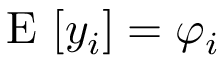Convert formula to latex. <formula><loc_0><loc_0><loc_500><loc_500>E [ y _ { i } ] = \varphi _ { i }</formula> 